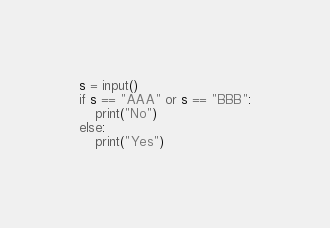Convert code to text. <code><loc_0><loc_0><loc_500><loc_500><_Python_>s = input()
if s == "AAA" or s == "BBB":
    print("No")
else:
    print("Yes")</code> 